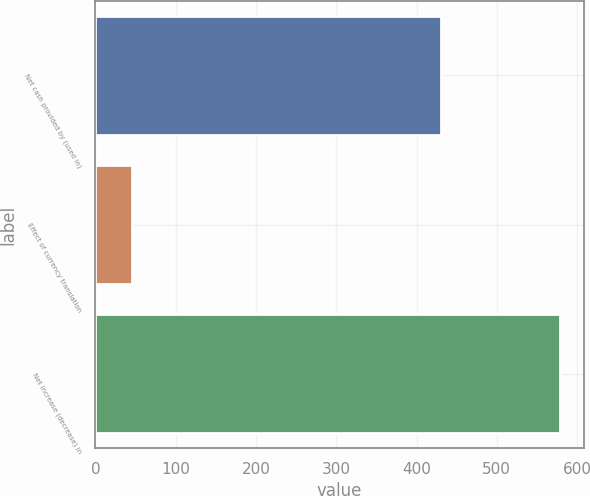<chart> <loc_0><loc_0><loc_500><loc_500><bar_chart><fcel>Net cash provided by (used in)<fcel>Effect of currency translation<fcel>Net increase (decrease) in<nl><fcel>431<fcel>46<fcel>579.2<nl></chart> 